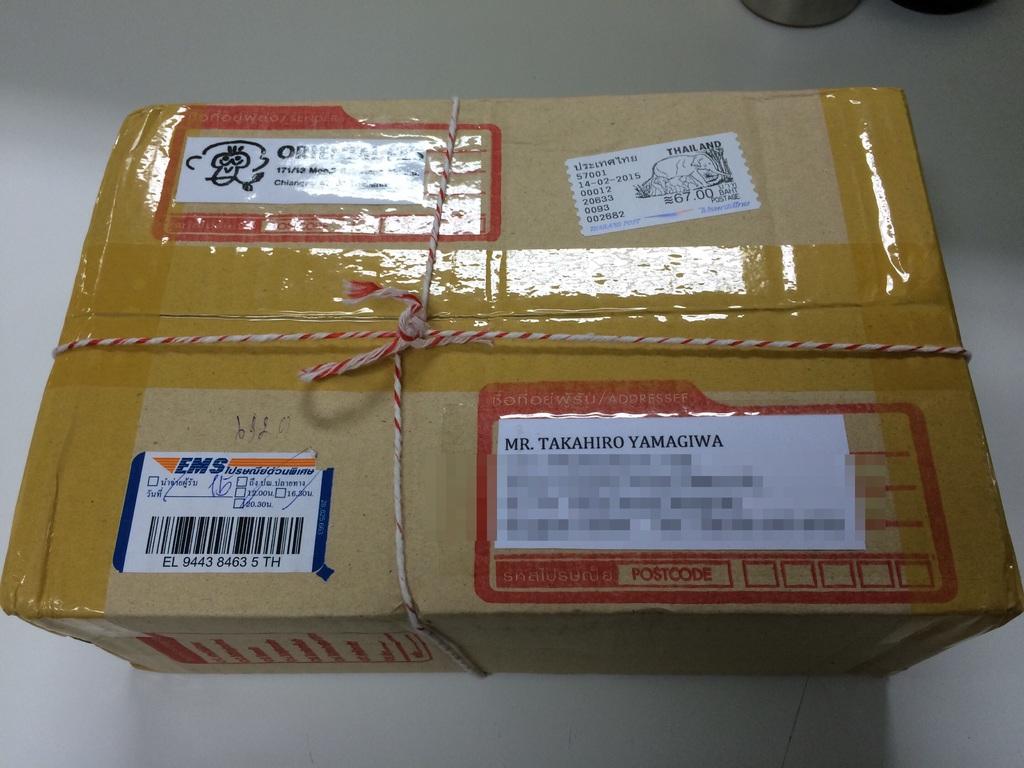Who is this percel for?
Provide a short and direct response. Mr. takahiro yamagiwa. What country did this package likely come from?
Offer a very short reply. Japan. 